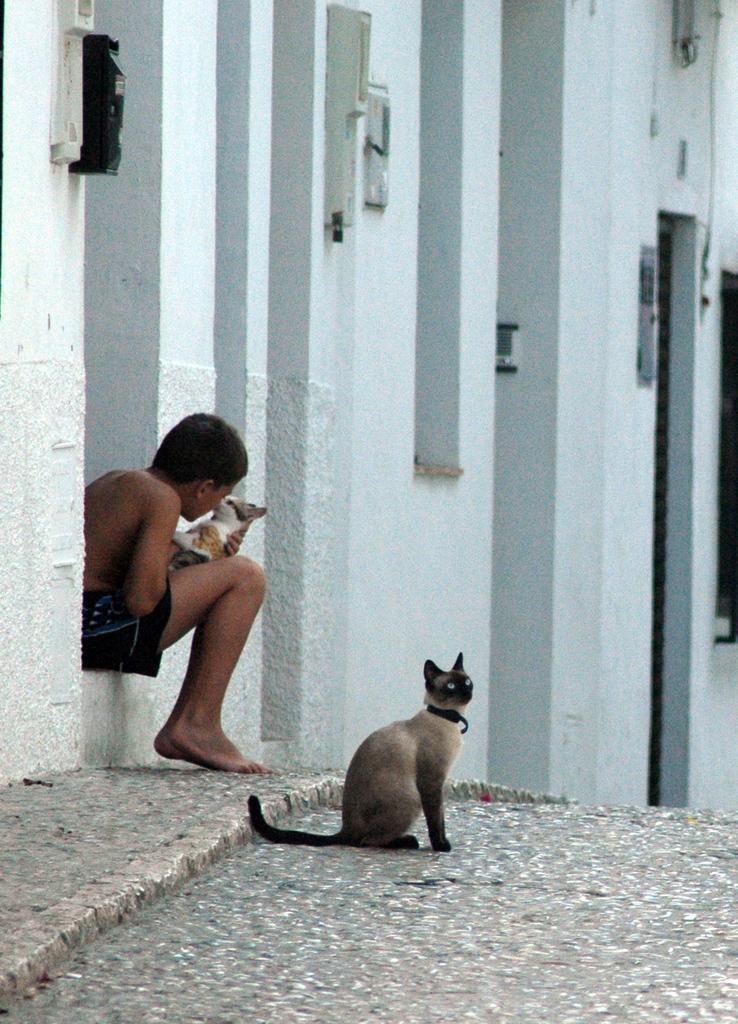How would you summarize this image in a sentence or two? In this image there is a boy siting on a wall and holding a cat in his hand, in front of him there is a cat on a path, in the background there is a wall. 